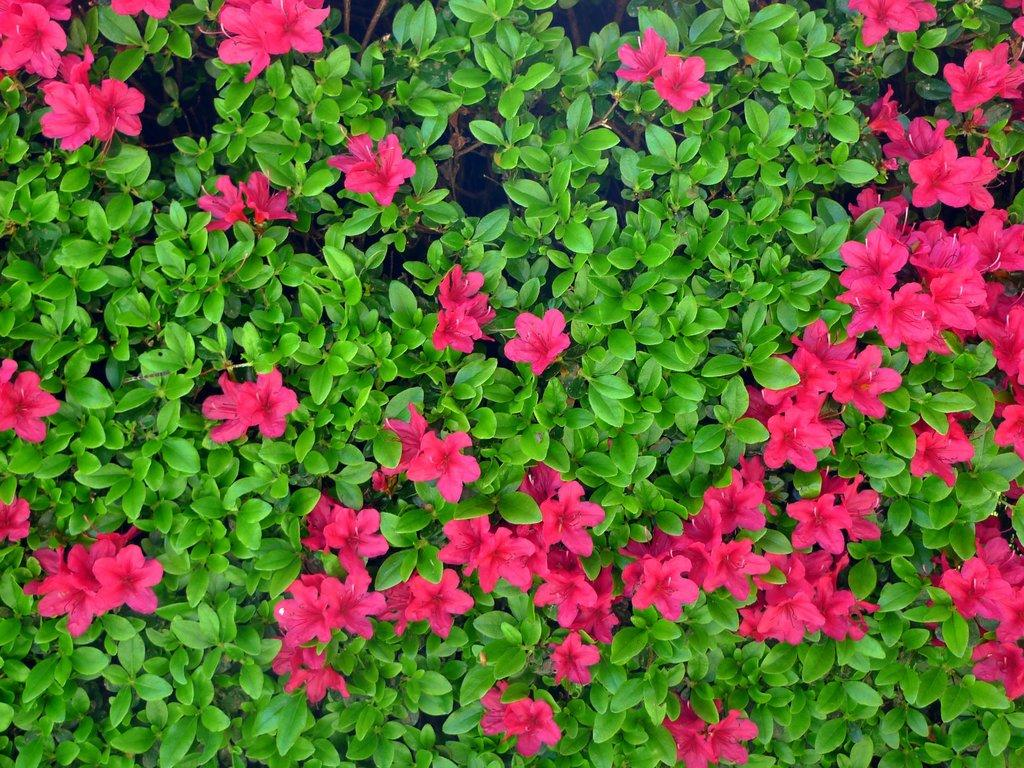What type of living organisms can be seen in the image? There are flowers on plants in the image. Can you describe the plants in the image? The plants in the image have flowers on them. How many houses are visible in the image? There are no houses present in the image; it features flowers on plants. What type of base is supporting the flowers in the image? The flowers are growing on plants, so there is no separate base supporting them in the image. 